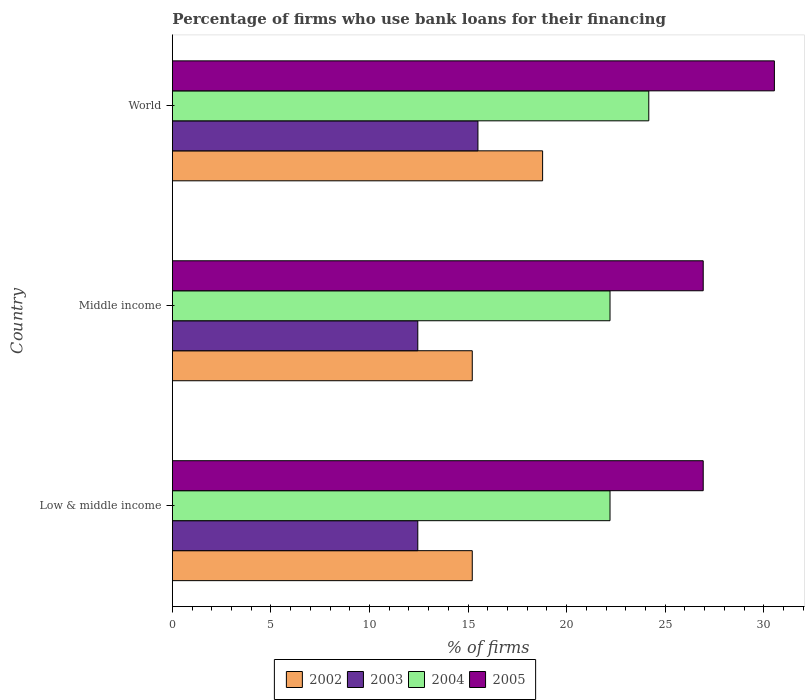How many groups of bars are there?
Make the answer very short. 3. Are the number of bars on each tick of the Y-axis equal?
Make the answer very short. Yes. How many bars are there on the 1st tick from the top?
Make the answer very short. 4. What is the label of the 1st group of bars from the top?
Your answer should be compact. World. In how many cases, is the number of bars for a given country not equal to the number of legend labels?
Ensure brevity in your answer.  0. What is the percentage of firms who use bank loans for their financing in 2003 in Middle income?
Provide a short and direct response. 12.45. Across all countries, what is the maximum percentage of firms who use bank loans for their financing in 2002?
Keep it short and to the point. 18.78. Across all countries, what is the minimum percentage of firms who use bank loans for their financing in 2002?
Your answer should be compact. 15.21. What is the total percentage of firms who use bank loans for their financing in 2005 in the graph?
Offer a terse response. 84.39. What is the difference between the percentage of firms who use bank loans for their financing in 2005 in Middle income and the percentage of firms who use bank loans for their financing in 2003 in Low & middle income?
Make the answer very short. 14.48. What is the average percentage of firms who use bank loans for their financing in 2003 per country?
Offer a terse response. 13.47. What is the difference between the percentage of firms who use bank loans for their financing in 2004 and percentage of firms who use bank loans for their financing in 2005 in World?
Offer a terse response. -6.37. What is the ratio of the percentage of firms who use bank loans for their financing in 2003 in Middle income to that in World?
Offer a terse response. 0.8. Is the percentage of firms who use bank loans for their financing in 2005 in Middle income less than that in World?
Provide a succinct answer. Yes. Is the difference between the percentage of firms who use bank loans for their financing in 2004 in Low & middle income and World greater than the difference between the percentage of firms who use bank loans for their financing in 2005 in Low & middle income and World?
Provide a succinct answer. Yes. What is the difference between the highest and the second highest percentage of firms who use bank loans for their financing in 2003?
Provide a short and direct response. 3.05. What is the difference between the highest and the lowest percentage of firms who use bank loans for their financing in 2005?
Your response must be concise. 3.61. Is the sum of the percentage of firms who use bank loans for their financing in 2002 in Low & middle income and World greater than the maximum percentage of firms who use bank loans for their financing in 2005 across all countries?
Your answer should be very brief. Yes. Is it the case that in every country, the sum of the percentage of firms who use bank loans for their financing in 2002 and percentage of firms who use bank loans for their financing in 2005 is greater than the sum of percentage of firms who use bank loans for their financing in 2004 and percentage of firms who use bank loans for their financing in 2003?
Offer a terse response. No. What does the 4th bar from the bottom in Low & middle income represents?
Offer a very short reply. 2005. How many bars are there?
Offer a very short reply. 12. How many countries are there in the graph?
Provide a succinct answer. 3. Are the values on the major ticks of X-axis written in scientific E-notation?
Make the answer very short. No. Where does the legend appear in the graph?
Your answer should be very brief. Bottom center. How many legend labels are there?
Give a very brief answer. 4. How are the legend labels stacked?
Your response must be concise. Horizontal. What is the title of the graph?
Provide a succinct answer. Percentage of firms who use bank loans for their financing. What is the label or title of the X-axis?
Provide a short and direct response. % of firms. What is the label or title of the Y-axis?
Provide a succinct answer. Country. What is the % of firms in 2002 in Low & middle income?
Offer a very short reply. 15.21. What is the % of firms of 2003 in Low & middle income?
Provide a short and direct response. 12.45. What is the % of firms in 2005 in Low & middle income?
Keep it short and to the point. 26.93. What is the % of firms in 2002 in Middle income?
Your answer should be very brief. 15.21. What is the % of firms of 2003 in Middle income?
Your answer should be compact. 12.45. What is the % of firms in 2004 in Middle income?
Offer a very short reply. 22.2. What is the % of firms of 2005 in Middle income?
Your answer should be very brief. 26.93. What is the % of firms in 2002 in World?
Give a very brief answer. 18.78. What is the % of firms of 2003 in World?
Provide a succinct answer. 15.5. What is the % of firms of 2004 in World?
Offer a very short reply. 24.17. What is the % of firms in 2005 in World?
Make the answer very short. 30.54. Across all countries, what is the maximum % of firms in 2002?
Offer a terse response. 18.78. Across all countries, what is the maximum % of firms of 2004?
Give a very brief answer. 24.17. Across all countries, what is the maximum % of firms of 2005?
Provide a succinct answer. 30.54. Across all countries, what is the minimum % of firms in 2002?
Make the answer very short. 15.21. Across all countries, what is the minimum % of firms in 2003?
Your answer should be very brief. 12.45. Across all countries, what is the minimum % of firms in 2005?
Give a very brief answer. 26.93. What is the total % of firms in 2002 in the graph?
Ensure brevity in your answer.  49.21. What is the total % of firms of 2003 in the graph?
Ensure brevity in your answer.  40.4. What is the total % of firms of 2004 in the graph?
Offer a very short reply. 68.57. What is the total % of firms of 2005 in the graph?
Offer a terse response. 84.39. What is the difference between the % of firms in 2002 in Low & middle income and that in Middle income?
Keep it short and to the point. 0. What is the difference between the % of firms of 2003 in Low & middle income and that in Middle income?
Your response must be concise. 0. What is the difference between the % of firms in 2005 in Low & middle income and that in Middle income?
Make the answer very short. 0. What is the difference between the % of firms in 2002 in Low & middle income and that in World?
Ensure brevity in your answer.  -3.57. What is the difference between the % of firms in 2003 in Low & middle income and that in World?
Provide a succinct answer. -3.05. What is the difference between the % of firms in 2004 in Low & middle income and that in World?
Offer a terse response. -1.97. What is the difference between the % of firms in 2005 in Low & middle income and that in World?
Your response must be concise. -3.61. What is the difference between the % of firms in 2002 in Middle income and that in World?
Your answer should be compact. -3.57. What is the difference between the % of firms in 2003 in Middle income and that in World?
Keep it short and to the point. -3.05. What is the difference between the % of firms in 2004 in Middle income and that in World?
Offer a very short reply. -1.97. What is the difference between the % of firms of 2005 in Middle income and that in World?
Keep it short and to the point. -3.61. What is the difference between the % of firms in 2002 in Low & middle income and the % of firms in 2003 in Middle income?
Give a very brief answer. 2.76. What is the difference between the % of firms in 2002 in Low & middle income and the % of firms in 2004 in Middle income?
Provide a succinct answer. -6.99. What is the difference between the % of firms in 2002 in Low & middle income and the % of firms in 2005 in Middle income?
Make the answer very short. -11.72. What is the difference between the % of firms in 2003 in Low & middle income and the % of firms in 2004 in Middle income?
Provide a short and direct response. -9.75. What is the difference between the % of firms of 2003 in Low & middle income and the % of firms of 2005 in Middle income?
Give a very brief answer. -14.48. What is the difference between the % of firms of 2004 in Low & middle income and the % of firms of 2005 in Middle income?
Your answer should be compact. -4.73. What is the difference between the % of firms of 2002 in Low & middle income and the % of firms of 2003 in World?
Offer a terse response. -0.29. What is the difference between the % of firms of 2002 in Low & middle income and the % of firms of 2004 in World?
Your response must be concise. -8.95. What is the difference between the % of firms of 2002 in Low & middle income and the % of firms of 2005 in World?
Offer a very short reply. -15.33. What is the difference between the % of firms in 2003 in Low & middle income and the % of firms in 2004 in World?
Your answer should be very brief. -11.72. What is the difference between the % of firms in 2003 in Low & middle income and the % of firms in 2005 in World?
Offer a terse response. -18.09. What is the difference between the % of firms in 2004 in Low & middle income and the % of firms in 2005 in World?
Provide a short and direct response. -8.34. What is the difference between the % of firms in 2002 in Middle income and the % of firms in 2003 in World?
Your answer should be very brief. -0.29. What is the difference between the % of firms of 2002 in Middle income and the % of firms of 2004 in World?
Ensure brevity in your answer.  -8.95. What is the difference between the % of firms in 2002 in Middle income and the % of firms in 2005 in World?
Your answer should be compact. -15.33. What is the difference between the % of firms of 2003 in Middle income and the % of firms of 2004 in World?
Provide a short and direct response. -11.72. What is the difference between the % of firms of 2003 in Middle income and the % of firms of 2005 in World?
Your response must be concise. -18.09. What is the difference between the % of firms in 2004 in Middle income and the % of firms in 2005 in World?
Offer a terse response. -8.34. What is the average % of firms in 2002 per country?
Your response must be concise. 16.4. What is the average % of firms in 2003 per country?
Your answer should be very brief. 13.47. What is the average % of firms of 2004 per country?
Offer a very short reply. 22.86. What is the average % of firms of 2005 per country?
Your answer should be very brief. 28.13. What is the difference between the % of firms in 2002 and % of firms in 2003 in Low & middle income?
Your answer should be compact. 2.76. What is the difference between the % of firms in 2002 and % of firms in 2004 in Low & middle income?
Offer a terse response. -6.99. What is the difference between the % of firms in 2002 and % of firms in 2005 in Low & middle income?
Offer a very short reply. -11.72. What is the difference between the % of firms in 2003 and % of firms in 2004 in Low & middle income?
Offer a terse response. -9.75. What is the difference between the % of firms in 2003 and % of firms in 2005 in Low & middle income?
Ensure brevity in your answer.  -14.48. What is the difference between the % of firms in 2004 and % of firms in 2005 in Low & middle income?
Offer a very short reply. -4.73. What is the difference between the % of firms of 2002 and % of firms of 2003 in Middle income?
Provide a succinct answer. 2.76. What is the difference between the % of firms in 2002 and % of firms in 2004 in Middle income?
Give a very brief answer. -6.99. What is the difference between the % of firms of 2002 and % of firms of 2005 in Middle income?
Provide a short and direct response. -11.72. What is the difference between the % of firms in 2003 and % of firms in 2004 in Middle income?
Your response must be concise. -9.75. What is the difference between the % of firms of 2003 and % of firms of 2005 in Middle income?
Your response must be concise. -14.48. What is the difference between the % of firms in 2004 and % of firms in 2005 in Middle income?
Your response must be concise. -4.73. What is the difference between the % of firms in 2002 and % of firms in 2003 in World?
Provide a succinct answer. 3.28. What is the difference between the % of firms in 2002 and % of firms in 2004 in World?
Your answer should be compact. -5.39. What is the difference between the % of firms in 2002 and % of firms in 2005 in World?
Provide a succinct answer. -11.76. What is the difference between the % of firms of 2003 and % of firms of 2004 in World?
Provide a succinct answer. -8.67. What is the difference between the % of firms of 2003 and % of firms of 2005 in World?
Provide a short and direct response. -15.04. What is the difference between the % of firms of 2004 and % of firms of 2005 in World?
Your answer should be compact. -6.37. What is the ratio of the % of firms of 2002 in Low & middle income to that in Middle income?
Provide a short and direct response. 1. What is the ratio of the % of firms in 2004 in Low & middle income to that in Middle income?
Ensure brevity in your answer.  1. What is the ratio of the % of firms in 2002 in Low & middle income to that in World?
Your answer should be compact. 0.81. What is the ratio of the % of firms of 2003 in Low & middle income to that in World?
Your answer should be compact. 0.8. What is the ratio of the % of firms of 2004 in Low & middle income to that in World?
Your response must be concise. 0.92. What is the ratio of the % of firms of 2005 in Low & middle income to that in World?
Offer a terse response. 0.88. What is the ratio of the % of firms in 2002 in Middle income to that in World?
Your answer should be very brief. 0.81. What is the ratio of the % of firms in 2003 in Middle income to that in World?
Offer a terse response. 0.8. What is the ratio of the % of firms in 2004 in Middle income to that in World?
Your answer should be compact. 0.92. What is the ratio of the % of firms in 2005 in Middle income to that in World?
Provide a succinct answer. 0.88. What is the difference between the highest and the second highest % of firms of 2002?
Give a very brief answer. 3.57. What is the difference between the highest and the second highest % of firms in 2003?
Provide a short and direct response. 3.05. What is the difference between the highest and the second highest % of firms of 2004?
Provide a short and direct response. 1.97. What is the difference between the highest and the second highest % of firms of 2005?
Your answer should be very brief. 3.61. What is the difference between the highest and the lowest % of firms of 2002?
Your answer should be very brief. 3.57. What is the difference between the highest and the lowest % of firms in 2003?
Provide a short and direct response. 3.05. What is the difference between the highest and the lowest % of firms of 2004?
Make the answer very short. 1.97. What is the difference between the highest and the lowest % of firms of 2005?
Give a very brief answer. 3.61. 